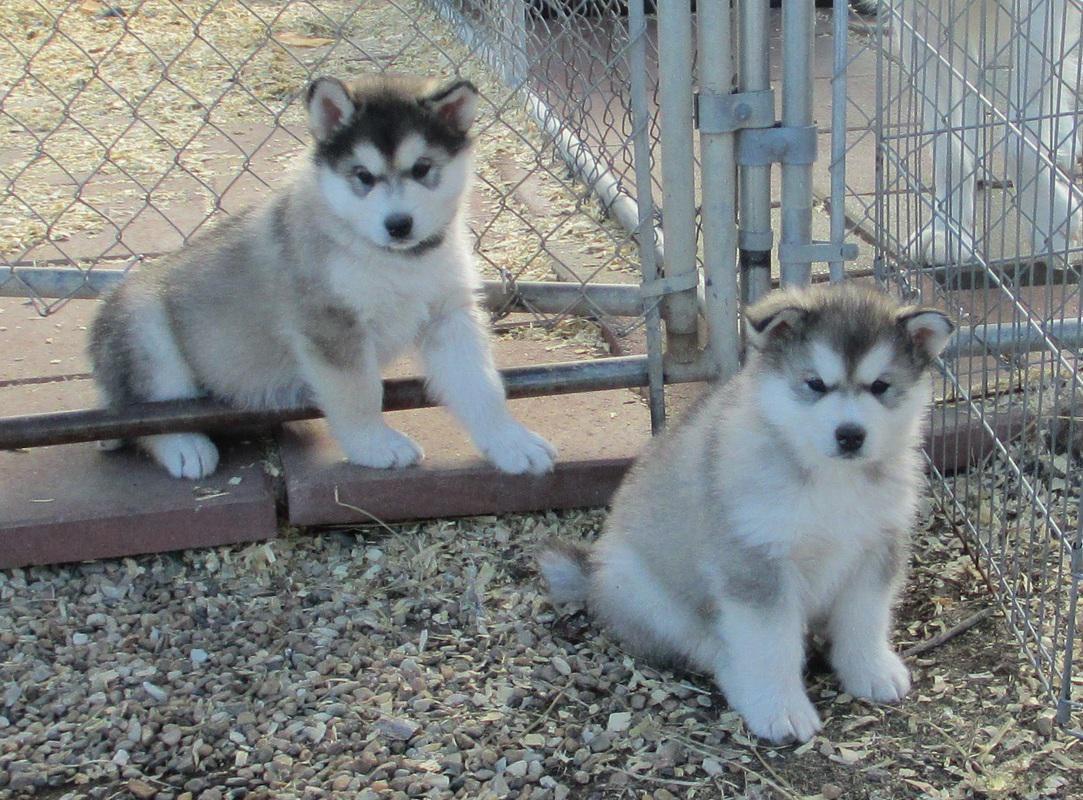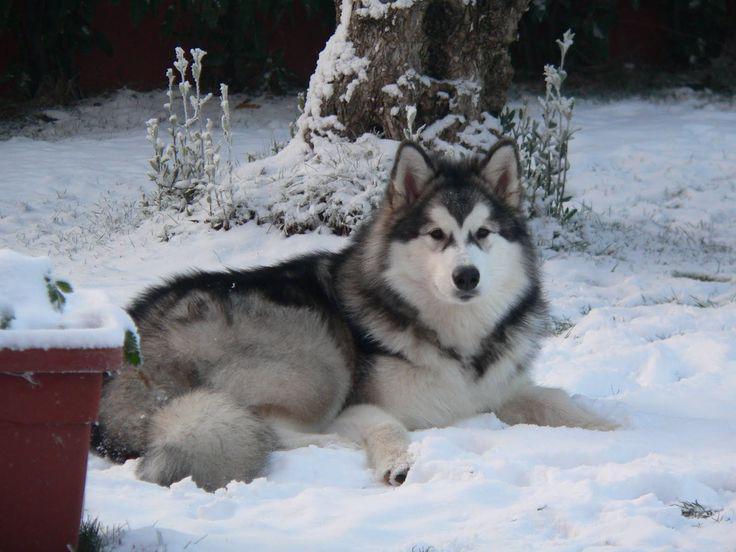The first image is the image on the left, the second image is the image on the right. Considering the images on both sides, is "In at least one image there are two pairs of dogs looking in different directions." valid? Answer yes or no. No. 